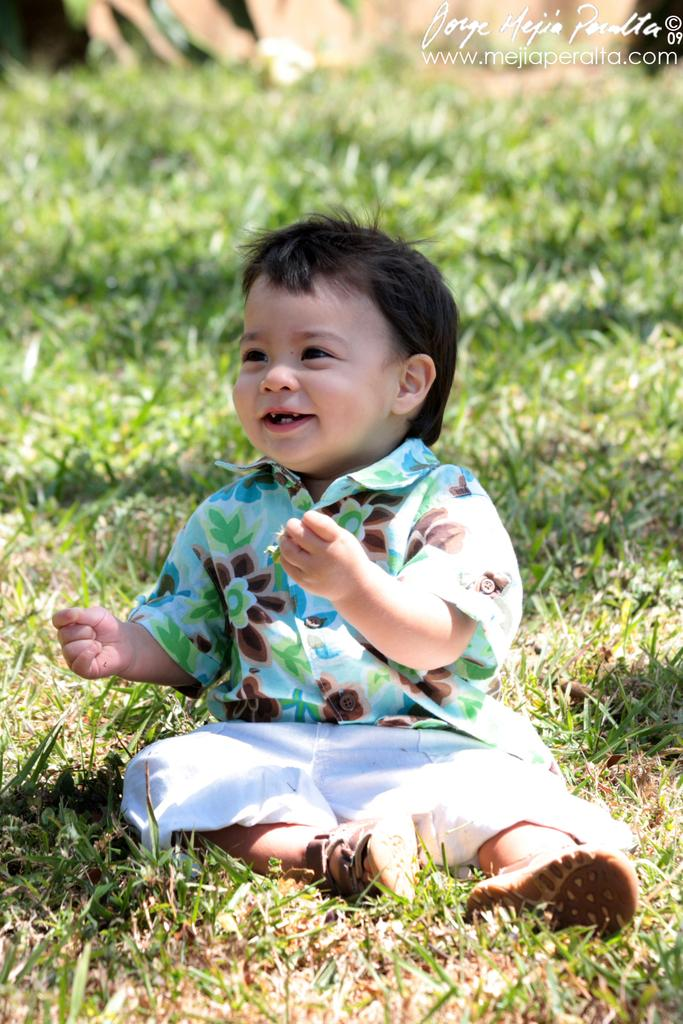What is the main subject of the image? The main subject of the image is a child. What is the child doing in the image? The child is sitting on the ground and smiling. What can be seen in the background of the image? There is grass in the background of the image. Is there any additional information about the image that might not be immediately visible? Yes, there is a watermark in the top right corner of the image. How many goldfish are swimming in the watermark in the image? There are no goldfish present in the image, as the watermark is not a body of water containing fish. 